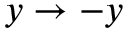Convert formula to latex. <formula><loc_0><loc_0><loc_500><loc_500>y \rightarrow - y</formula> 